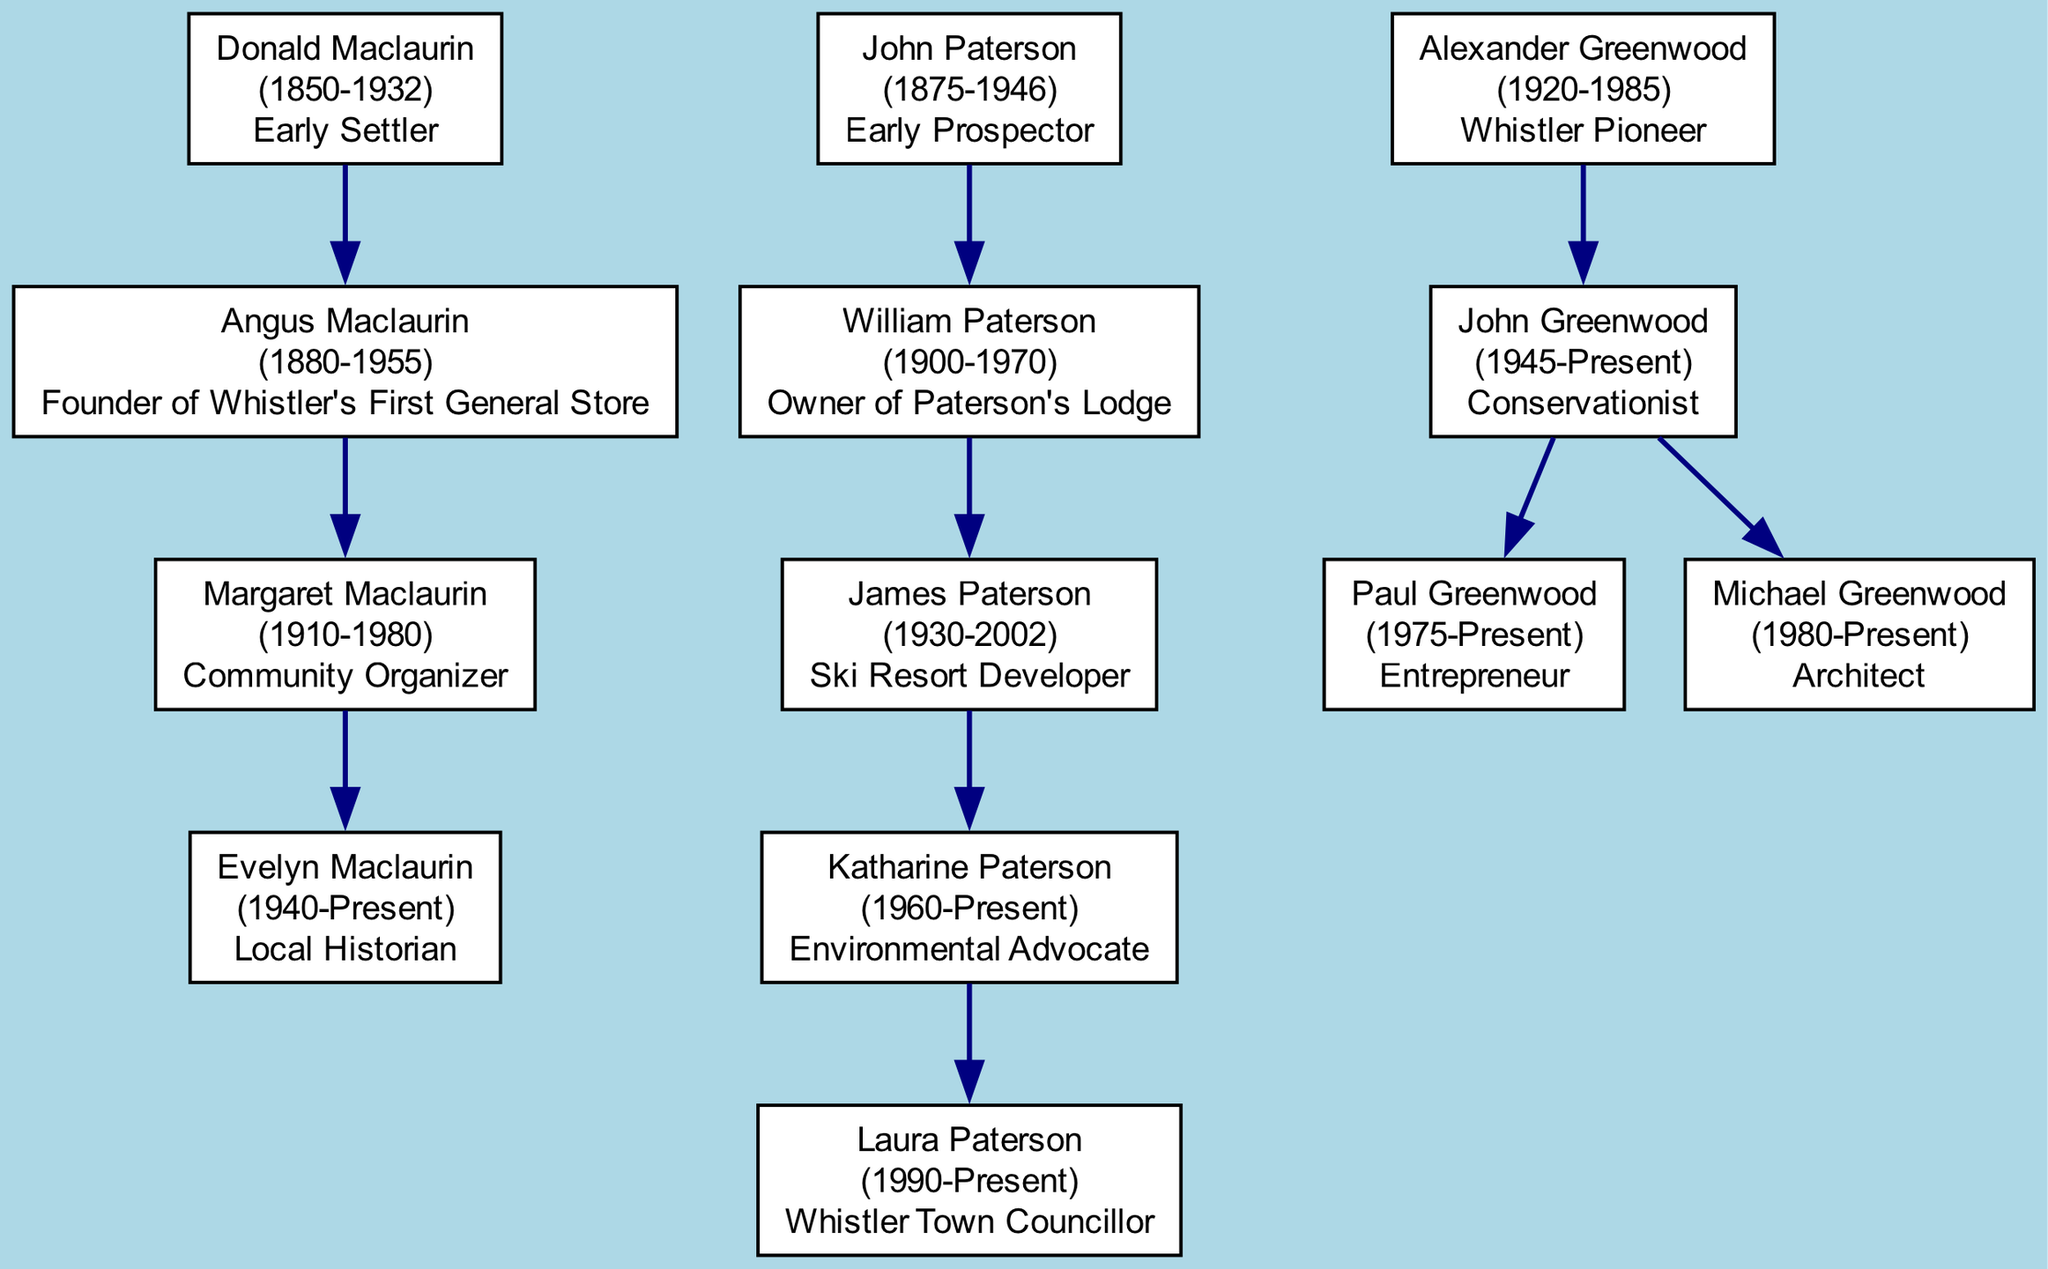What is Donald Maclaurin's role? The diagram shows that Donald Maclaurin is classified as an "Early Settler".
Answer: Early Settler Who is the founder of Whistler's first general store? According to the diagram, Angus Maclaurin, the son of Donald Maclaurin, is the founder of Whistler's First General Store.
Answer: Angus Maclaurin How many children does John Paterson have? By examining the diagram, John Paterson has one child, William Paterson.
Answer: 1 What is the birth year of Evelyn Maclaurin? The diagram indicates that Evelyn Maclaurin was born in 1940.
Answer: 1940 Who is the environmental advocate in the Paterson family? The diagram shows that Katharine Paterson is identified as the environmental advocate in her family.
Answer: Katharine Paterson Which family does John Greenwood belong to? From the diagram, it is clear that John Greenwood belongs to the Greenwood family.
Answer: Greenwood Who is the local historian? The diagram indicates that Evelyn Maclaurin holds the title of local historian.
Answer: Evelyn Maclaurin How many grandchildren does Alexander Greenwood have? By reviewing the diagram, Alexander Greenwood has two grandchildren: Paul Greenwood and Michael Greenwood.
Answer: 2 Which member is a ski resort developer? The diagram shows that James Paterson is the member recognized as a ski resort developer.
Answer: James Paterson 